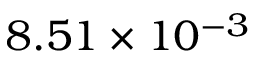Convert formula to latex. <formula><loc_0><loc_0><loc_500><loc_500>8 . 5 1 \times 1 0 ^ { - 3 }</formula> 